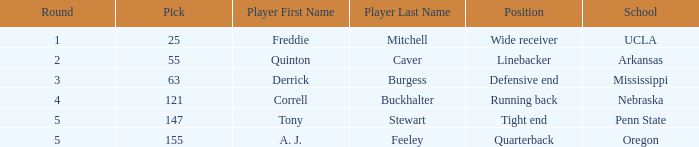Who was the player who was pick number 147? Tony Stewart. 